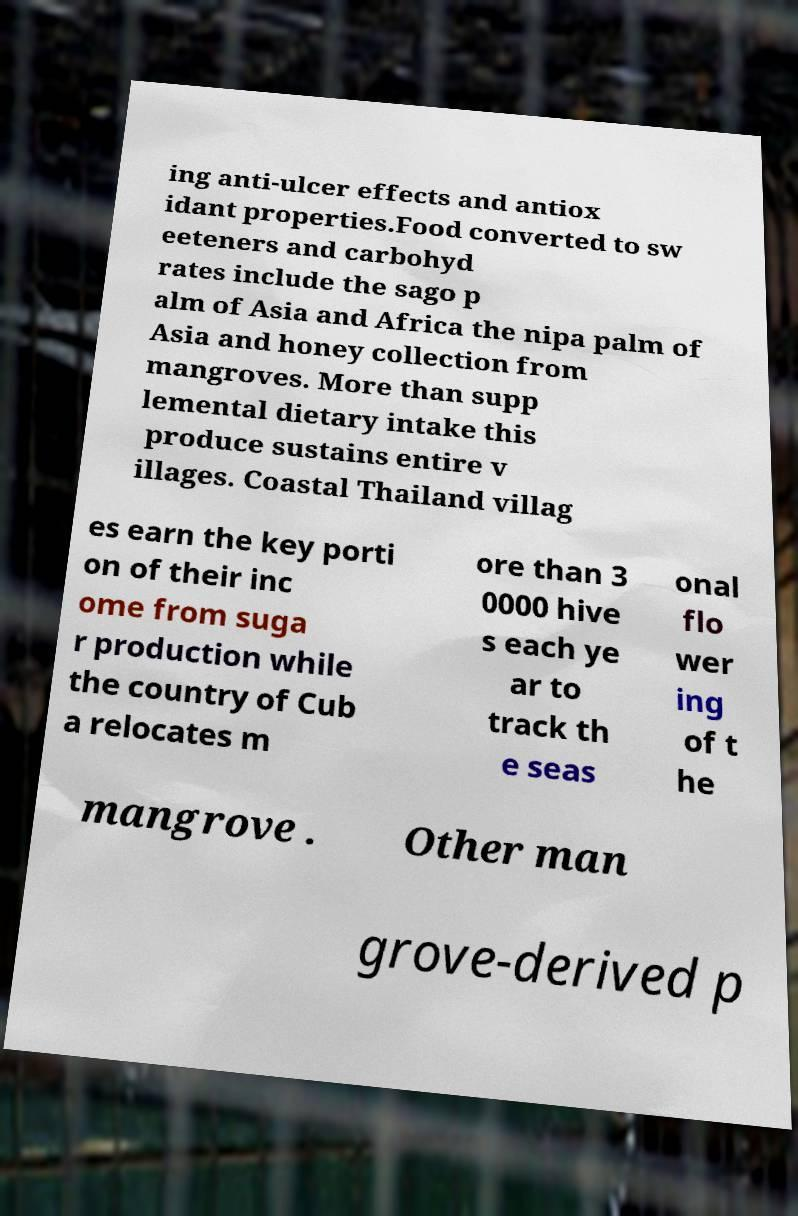There's text embedded in this image that I need extracted. Can you transcribe it verbatim? ing anti-ulcer effects and antiox idant properties.Food converted to sw eeteners and carbohyd rates include the sago p alm of Asia and Africa the nipa palm of Asia and honey collection from mangroves. More than supp lemental dietary intake this produce sustains entire v illages. Coastal Thailand villag es earn the key porti on of their inc ome from suga r production while the country of Cub a relocates m ore than 3 0000 hive s each ye ar to track th e seas onal flo wer ing of t he mangrove . Other man grove-derived p 